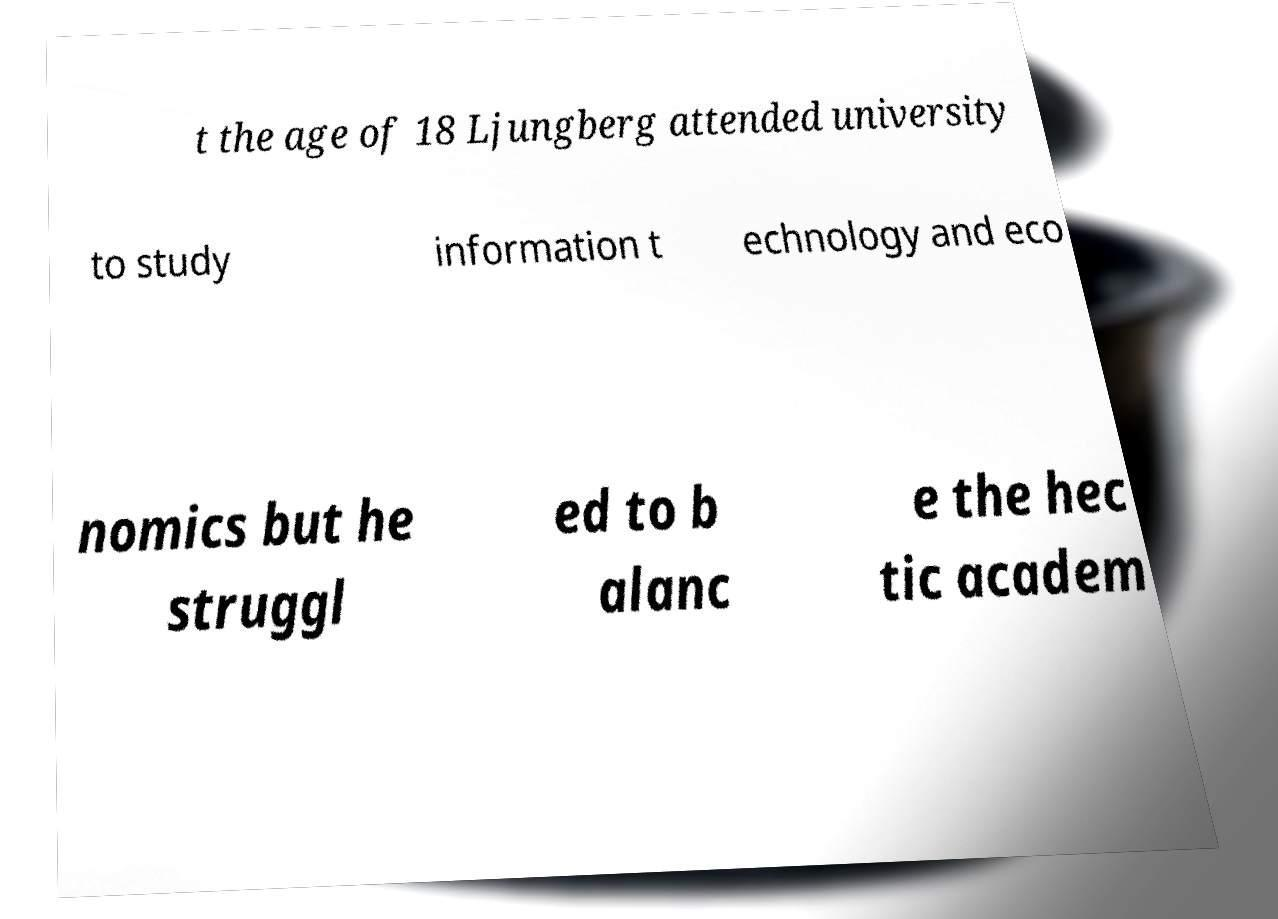Could you extract and type out the text from this image? t the age of 18 Ljungberg attended university to study information t echnology and eco nomics but he struggl ed to b alanc e the hec tic academ 